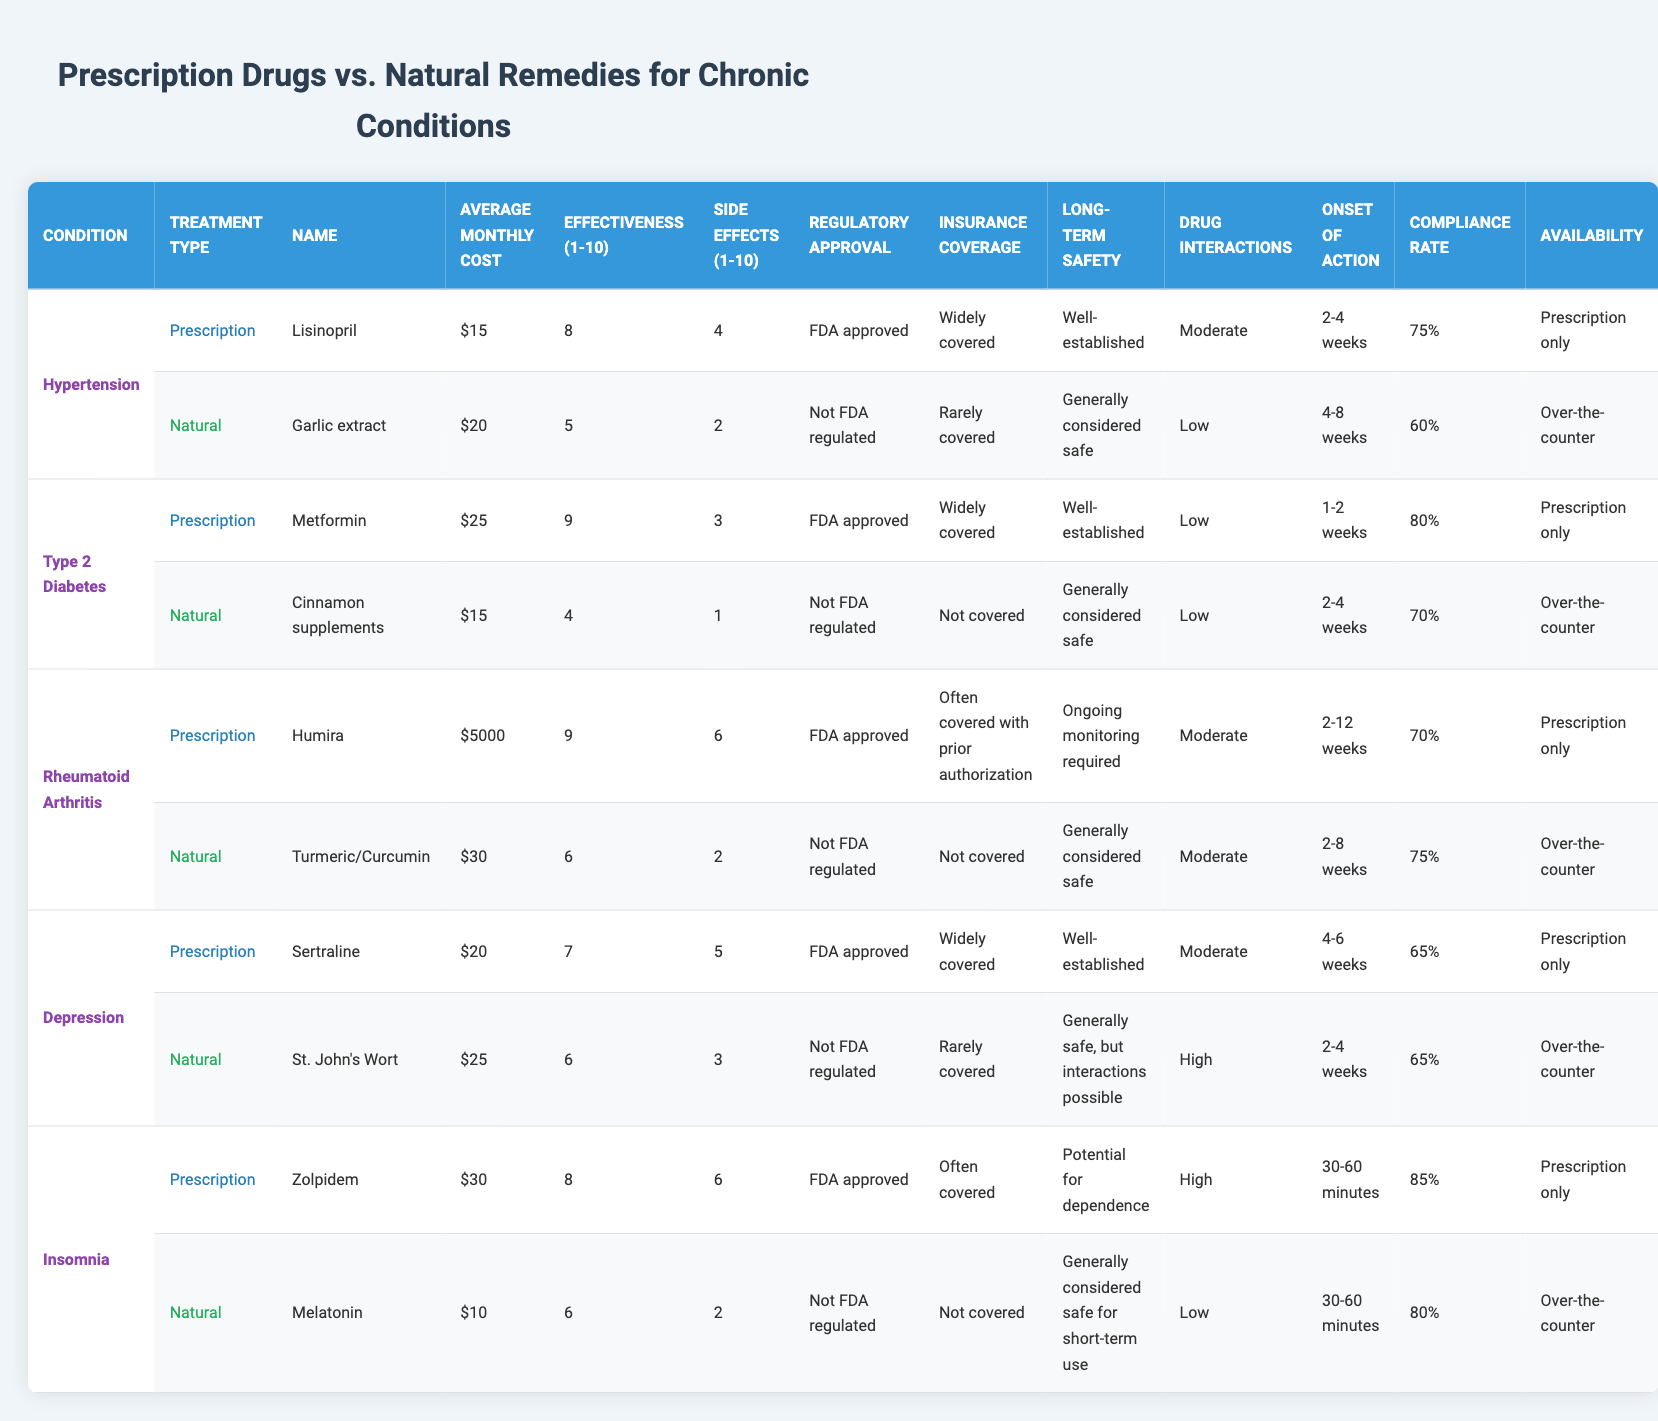What is the average monthly cost of Lisinopril? The average monthly cost of Lisinopril, which is used to treat hypertension, is listed directly in the table under "Average Monthly Cost" for Lisinopril. It shows $15.
Answer: 15 How many conditions have a patient compliance rate of at least 80%? Looking at the "Patient Compliance Rate" column, Metformin shows 80% and Zolpidem shows 85%, and they are the only two treatments that meet this criterion. Thus, there are two conditions with at least 80% compliance.
Answer: 2 Which natural remedy has the highest effectiveness rating? The effectiveness rating for natural remedies can be found in the "Effectiveness" column for each natural remedy. The highest value is 6, which corresponds to both Turmeric/Curcumin and St. John's Wort.
Answer: 6 What is the difference in average monthly cost between Humira and its natural alternative? The average monthly cost of Humira is $5000, and the average cost of its alternative, Turmeric/Curcumin, is $30. The difference is calculated as 5000 - 30 = 4970.
Answer: 4970 Is Sertraline covered by insurance? Looking at the "Insurance Coverage" column for Sertraline, it clearly states that it is widely covered.
Answer: Yes Which treatment for depression shows the highest side effects severity? The side effects severity for Sertraline is noted as 5 and for St. John's Wort, it is 3. The higher value of 5 indicates that Sertraline shows the highest severity for depression treatments.
Answer: Sertraline What is the long-term safety profile of Zolpidem? The table indicates that the long-term safety profile of Zolpidem is "Potential for dependence," which clarifies the safety concerns associated with its use.
Answer: Potential for dependence Which treatment for insomnia has a lower average monthly cost and how much lower? Melatonin has an average monthly cost of $10, and Zolpidem costs $30. The difference is calculated as 30 - 10 = 20. Therefore, Melatonin is $20 lower.
Answer: 20 What are the common regulations regarding the FDA approval for natural remedies? In the table, all natural remedies are noted as "Not FDA regulated," indicating that none of them have undergone the same approval process as prescription medications.
Answer: None are FDA regulated 